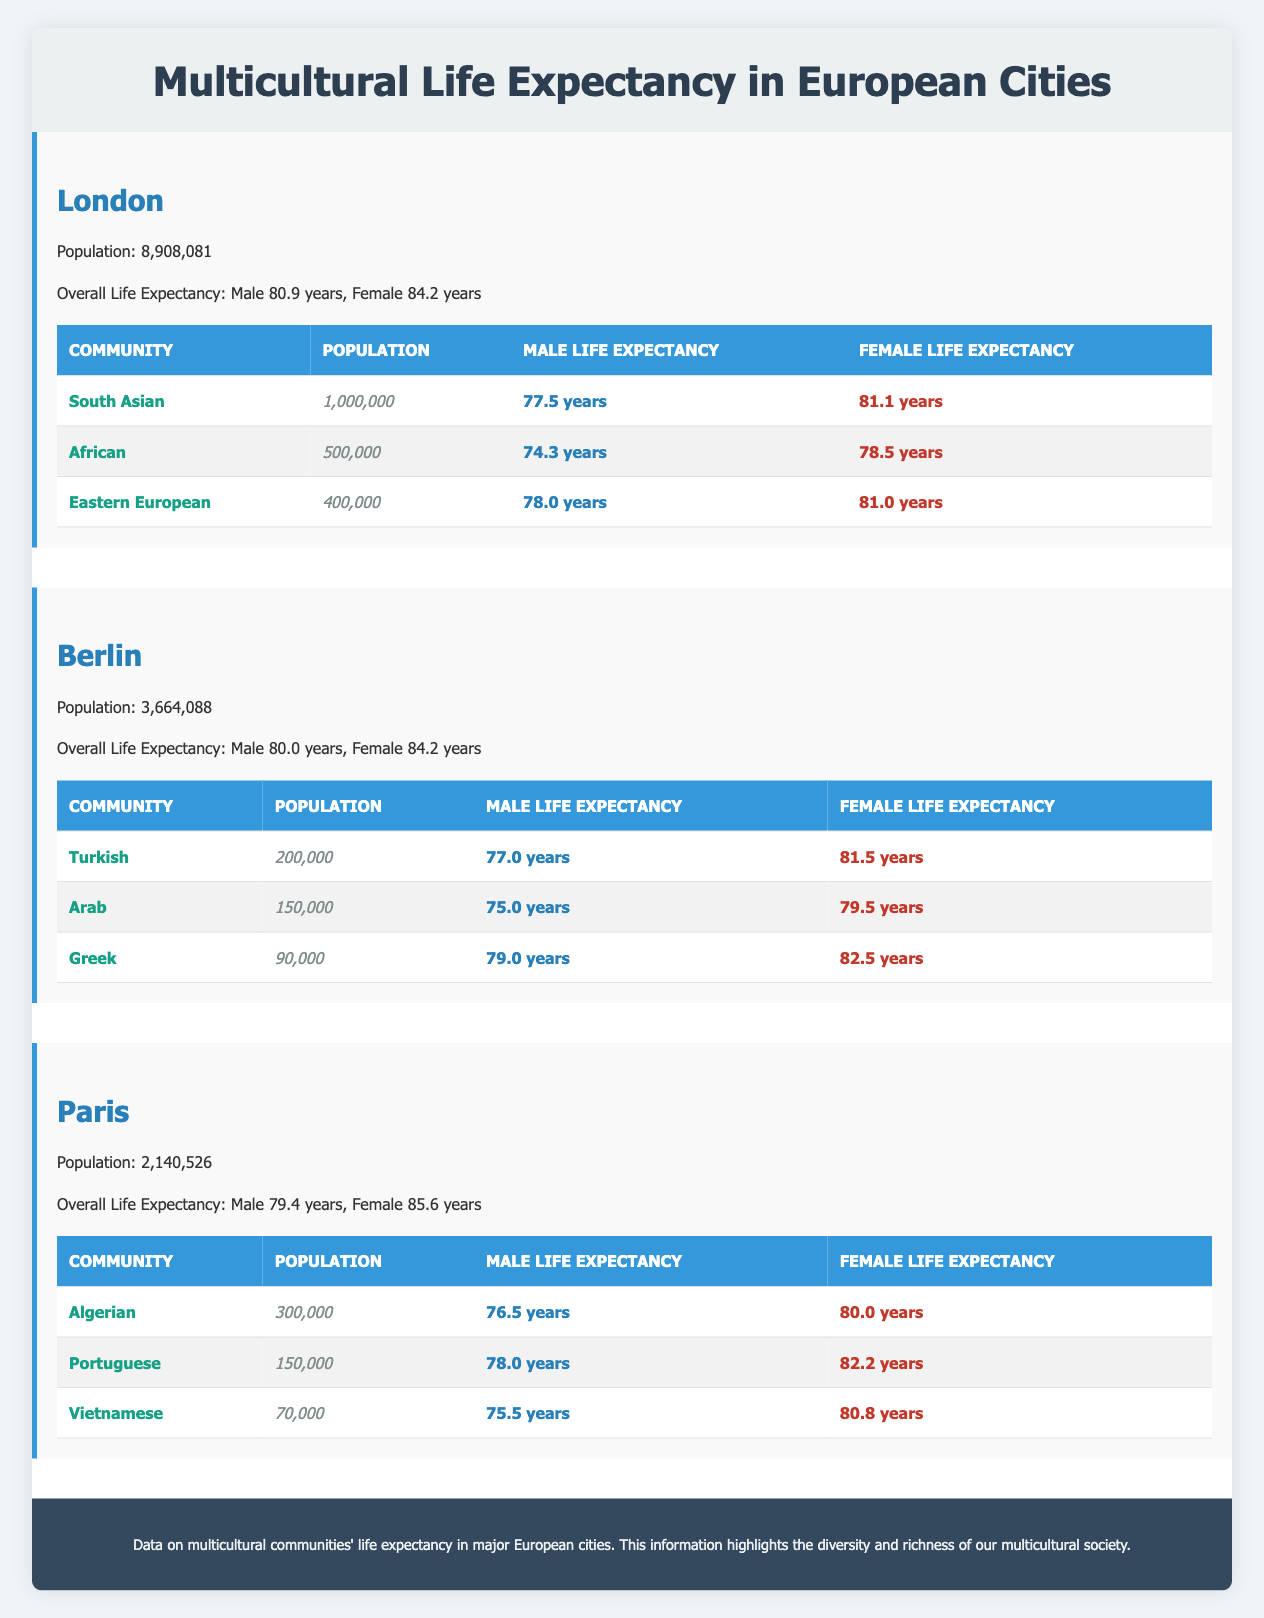What is the male life expectancy of the African community in London? The table specifies the lifespan data for London, where it lists the African community. It shows a male life expectancy of 74.3 years for the African community specifically under London.
Answer: 74.3 years Which city has the highest overall female life expectancy? By examining the overall life expectancies listed for each city, we find that Paris has the highest female life expectancy at 85.6 years, compared to London (84.2 years) and Berlin (84.2 years).
Answer: Paris How many total South Asian individuals are in the communities across all cities? We can find that in London, the South Asian community has a population of 1,000,000. In the other cities, there are no South Asian communities mentioned. Therefore, the total is simply 1,000,000.
Answer: 1,000,000 Is the life expectancy of Turkish males higher than that of Algerian males? The life expectancy of Turkish males in Berlin is listed as 77.0 years and for Algerian males in Paris as 76.5 years. Since 77.0 years is greater than 76.5 years, we can determine that Turkish males do have a higher life expectancy.
Answer: Yes What is the average male life expectancy for the communities listed in Berlin? We first find the male life expectancies for each community: Turkish (77.0 years), Arab (75.0 years), and Greek (79.0 years). We sum them up: 77.0 + 75.0 + 79.0 = 231. Next, we divide by the number of communities, which is 3. Thus, the average life expectancy is 231 / 3 = 77.0 years.
Answer: 77.0 years What percentage of the total population in London is South Asian? The total population in London is 8,908,081 and the South Asian community has a population of 1,000,000. To find the percentage, we calculate (1,000,000 / 8,908,081) * 100, which is approximately 11.24%.
Answer: 11.24% Are there more females than males in the Eastern European community in London? The lifespan data shows that for Eastern Europeans in London, the male life expectancy is 78.0 years, and the female life expectancy is 81.0 years. Therefore, the female population is generally expected to be greater than the male population based on life expectancy.
Answer: Yes Which community in Paris has the lowest male life expectancy? Examining the data for Paris, the communities' male life expectancies are Algerian (76.5 years), Portuguese (78.0 years), and Vietnamese (75.5 years). The lowest among these is for the Vietnamese community at 75.5 years.
Answer: Vietnamese community What is the total female population in the Turkish and Arab communities in Berlin? The table shows the Turkish community population as 200,000 and the Arab community population as 150,000. Adding these together gives us 200,000 + 150,000 = 350,000.
Answer: 350,000 